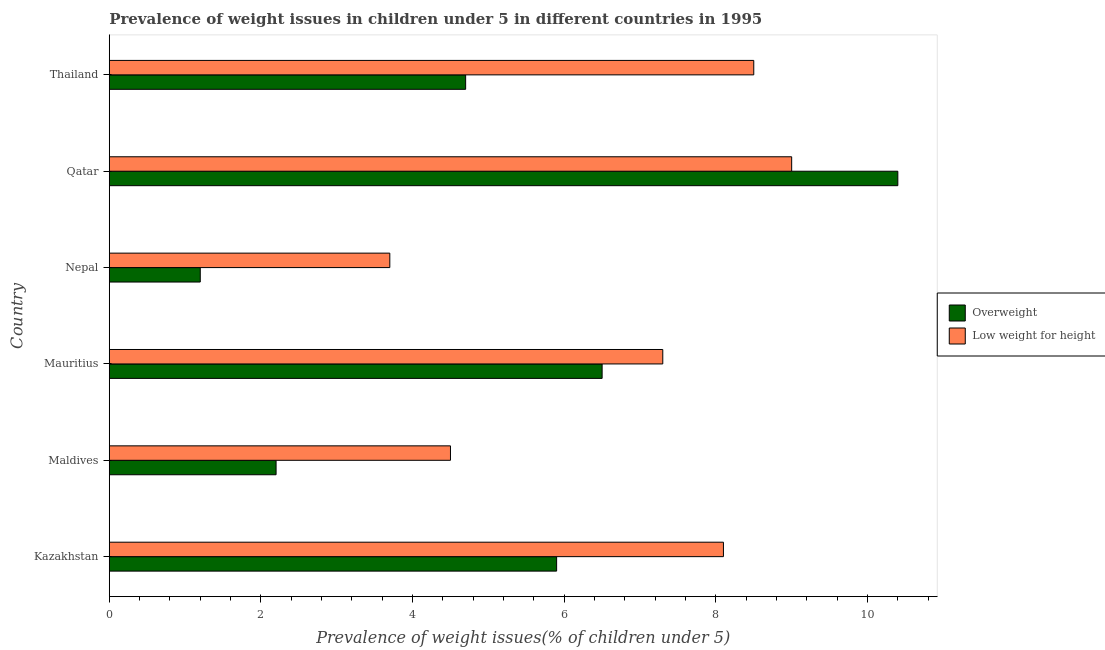How many groups of bars are there?
Keep it short and to the point. 6. Are the number of bars per tick equal to the number of legend labels?
Provide a short and direct response. Yes. What is the label of the 3rd group of bars from the top?
Provide a short and direct response. Nepal. What is the percentage of overweight children in Thailand?
Give a very brief answer. 4.7. Across all countries, what is the maximum percentage of underweight children?
Provide a succinct answer. 9. Across all countries, what is the minimum percentage of underweight children?
Give a very brief answer. 3.7. In which country was the percentage of overweight children maximum?
Offer a very short reply. Qatar. In which country was the percentage of underweight children minimum?
Offer a terse response. Nepal. What is the total percentage of overweight children in the graph?
Provide a succinct answer. 30.9. What is the difference between the percentage of overweight children in Kazakhstan and the percentage of underweight children in Nepal?
Your answer should be very brief. 2.2. What is the average percentage of overweight children per country?
Your response must be concise. 5.15. In how many countries, is the percentage of overweight children greater than 10 %?
Give a very brief answer. 1. What is the ratio of the percentage of underweight children in Kazakhstan to that in Nepal?
Make the answer very short. 2.19. Is the percentage of overweight children in Nepal less than that in Thailand?
Keep it short and to the point. Yes. Is the difference between the percentage of overweight children in Nepal and Qatar greater than the difference between the percentage of underweight children in Nepal and Qatar?
Offer a very short reply. No. What is the difference between the highest and the lowest percentage of underweight children?
Make the answer very short. 5.3. Is the sum of the percentage of underweight children in Nepal and Qatar greater than the maximum percentage of overweight children across all countries?
Offer a terse response. Yes. What does the 2nd bar from the top in Maldives represents?
Make the answer very short. Overweight. What does the 2nd bar from the bottom in Mauritius represents?
Make the answer very short. Low weight for height. What is the difference between two consecutive major ticks on the X-axis?
Your answer should be compact. 2. What is the title of the graph?
Your answer should be very brief. Prevalence of weight issues in children under 5 in different countries in 1995. Does "Males" appear as one of the legend labels in the graph?
Your answer should be compact. No. What is the label or title of the X-axis?
Your answer should be compact. Prevalence of weight issues(% of children under 5). What is the label or title of the Y-axis?
Offer a terse response. Country. What is the Prevalence of weight issues(% of children under 5) in Overweight in Kazakhstan?
Your answer should be very brief. 5.9. What is the Prevalence of weight issues(% of children under 5) of Low weight for height in Kazakhstan?
Offer a very short reply. 8.1. What is the Prevalence of weight issues(% of children under 5) in Overweight in Maldives?
Give a very brief answer. 2.2. What is the Prevalence of weight issues(% of children under 5) of Overweight in Mauritius?
Your response must be concise. 6.5. What is the Prevalence of weight issues(% of children under 5) of Low weight for height in Mauritius?
Give a very brief answer. 7.3. What is the Prevalence of weight issues(% of children under 5) in Overweight in Nepal?
Give a very brief answer. 1.2. What is the Prevalence of weight issues(% of children under 5) in Low weight for height in Nepal?
Give a very brief answer. 3.7. What is the Prevalence of weight issues(% of children under 5) of Overweight in Qatar?
Ensure brevity in your answer.  10.4. What is the Prevalence of weight issues(% of children under 5) in Overweight in Thailand?
Provide a succinct answer. 4.7. Across all countries, what is the maximum Prevalence of weight issues(% of children under 5) of Overweight?
Make the answer very short. 10.4. Across all countries, what is the maximum Prevalence of weight issues(% of children under 5) of Low weight for height?
Provide a short and direct response. 9. Across all countries, what is the minimum Prevalence of weight issues(% of children under 5) in Overweight?
Make the answer very short. 1.2. Across all countries, what is the minimum Prevalence of weight issues(% of children under 5) of Low weight for height?
Make the answer very short. 3.7. What is the total Prevalence of weight issues(% of children under 5) of Overweight in the graph?
Keep it short and to the point. 30.9. What is the total Prevalence of weight issues(% of children under 5) of Low weight for height in the graph?
Provide a succinct answer. 41.1. What is the difference between the Prevalence of weight issues(% of children under 5) in Low weight for height in Kazakhstan and that in Maldives?
Your answer should be very brief. 3.6. What is the difference between the Prevalence of weight issues(% of children under 5) in Overweight in Kazakhstan and that in Mauritius?
Your answer should be very brief. -0.6. What is the difference between the Prevalence of weight issues(% of children under 5) in Low weight for height in Kazakhstan and that in Mauritius?
Make the answer very short. 0.8. What is the difference between the Prevalence of weight issues(% of children under 5) of Overweight in Kazakhstan and that in Nepal?
Ensure brevity in your answer.  4.7. What is the difference between the Prevalence of weight issues(% of children under 5) in Overweight in Kazakhstan and that in Qatar?
Provide a succinct answer. -4.5. What is the difference between the Prevalence of weight issues(% of children under 5) in Overweight in Kazakhstan and that in Thailand?
Provide a short and direct response. 1.2. What is the difference between the Prevalence of weight issues(% of children under 5) of Low weight for height in Kazakhstan and that in Thailand?
Offer a terse response. -0.4. What is the difference between the Prevalence of weight issues(% of children under 5) of Low weight for height in Maldives and that in Mauritius?
Ensure brevity in your answer.  -2.8. What is the difference between the Prevalence of weight issues(% of children under 5) of Low weight for height in Maldives and that in Thailand?
Ensure brevity in your answer.  -4. What is the difference between the Prevalence of weight issues(% of children under 5) of Low weight for height in Mauritius and that in Nepal?
Give a very brief answer. 3.6. What is the difference between the Prevalence of weight issues(% of children under 5) in Overweight in Mauritius and that in Qatar?
Provide a short and direct response. -3.9. What is the difference between the Prevalence of weight issues(% of children under 5) in Low weight for height in Mauritius and that in Qatar?
Provide a succinct answer. -1.7. What is the difference between the Prevalence of weight issues(% of children under 5) of Low weight for height in Mauritius and that in Thailand?
Ensure brevity in your answer.  -1.2. What is the difference between the Prevalence of weight issues(% of children under 5) of Low weight for height in Nepal and that in Qatar?
Give a very brief answer. -5.3. What is the difference between the Prevalence of weight issues(% of children under 5) of Overweight in Nepal and that in Thailand?
Offer a terse response. -3.5. What is the difference between the Prevalence of weight issues(% of children under 5) in Overweight in Qatar and that in Thailand?
Your answer should be compact. 5.7. What is the difference between the Prevalence of weight issues(% of children under 5) in Overweight in Kazakhstan and the Prevalence of weight issues(% of children under 5) in Low weight for height in Maldives?
Offer a terse response. 1.4. What is the difference between the Prevalence of weight issues(% of children under 5) in Overweight in Maldives and the Prevalence of weight issues(% of children under 5) in Low weight for height in Mauritius?
Provide a succinct answer. -5.1. What is the difference between the Prevalence of weight issues(% of children under 5) in Overweight in Maldives and the Prevalence of weight issues(% of children under 5) in Low weight for height in Nepal?
Your answer should be very brief. -1.5. What is the difference between the Prevalence of weight issues(% of children under 5) of Overweight in Maldives and the Prevalence of weight issues(% of children under 5) of Low weight for height in Thailand?
Your answer should be very brief. -6.3. What is the difference between the Prevalence of weight issues(% of children under 5) in Overweight in Mauritius and the Prevalence of weight issues(% of children under 5) in Low weight for height in Thailand?
Offer a very short reply. -2. What is the difference between the Prevalence of weight issues(% of children under 5) in Overweight in Nepal and the Prevalence of weight issues(% of children under 5) in Low weight for height in Thailand?
Give a very brief answer. -7.3. What is the difference between the Prevalence of weight issues(% of children under 5) in Overweight in Qatar and the Prevalence of weight issues(% of children under 5) in Low weight for height in Thailand?
Offer a very short reply. 1.9. What is the average Prevalence of weight issues(% of children under 5) in Overweight per country?
Keep it short and to the point. 5.15. What is the average Prevalence of weight issues(% of children under 5) in Low weight for height per country?
Your response must be concise. 6.85. What is the difference between the Prevalence of weight issues(% of children under 5) in Overweight and Prevalence of weight issues(% of children under 5) in Low weight for height in Maldives?
Make the answer very short. -2.3. What is the difference between the Prevalence of weight issues(% of children under 5) of Overweight and Prevalence of weight issues(% of children under 5) of Low weight for height in Nepal?
Offer a terse response. -2.5. What is the difference between the Prevalence of weight issues(% of children under 5) in Overweight and Prevalence of weight issues(% of children under 5) in Low weight for height in Thailand?
Your response must be concise. -3.8. What is the ratio of the Prevalence of weight issues(% of children under 5) in Overweight in Kazakhstan to that in Maldives?
Offer a very short reply. 2.68. What is the ratio of the Prevalence of weight issues(% of children under 5) in Low weight for height in Kazakhstan to that in Maldives?
Your answer should be very brief. 1.8. What is the ratio of the Prevalence of weight issues(% of children under 5) of Overweight in Kazakhstan to that in Mauritius?
Give a very brief answer. 0.91. What is the ratio of the Prevalence of weight issues(% of children under 5) of Low weight for height in Kazakhstan to that in Mauritius?
Make the answer very short. 1.11. What is the ratio of the Prevalence of weight issues(% of children under 5) of Overweight in Kazakhstan to that in Nepal?
Ensure brevity in your answer.  4.92. What is the ratio of the Prevalence of weight issues(% of children under 5) of Low weight for height in Kazakhstan to that in Nepal?
Give a very brief answer. 2.19. What is the ratio of the Prevalence of weight issues(% of children under 5) of Overweight in Kazakhstan to that in Qatar?
Offer a terse response. 0.57. What is the ratio of the Prevalence of weight issues(% of children under 5) of Low weight for height in Kazakhstan to that in Qatar?
Keep it short and to the point. 0.9. What is the ratio of the Prevalence of weight issues(% of children under 5) of Overweight in Kazakhstan to that in Thailand?
Keep it short and to the point. 1.26. What is the ratio of the Prevalence of weight issues(% of children under 5) in Low weight for height in Kazakhstan to that in Thailand?
Keep it short and to the point. 0.95. What is the ratio of the Prevalence of weight issues(% of children under 5) in Overweight in Maldives to that in Mauritius?
Ensure brevity in your answer.  0.34. What is the ratio of the Prevalence of weight issues(% of children under 5) of Low weight for height in Maldives to that in Mauritius?
Your response must be concise. 0.62. What is the ratio of the Prevalence of weight issues(% of children under 5) in Overweight in Maldives to that in Nepal?
Your answer should be very brief. 1.83. What is the ratio of the Prevalence of weight issues(% of children under 5) in Low weight for height in Maldives to that in Nepal?
Offer a very short reply. 1.22. What is the ratio of the Prevalence of weight issues(% of children under 5) in Overweight in Maldives to that in Qatar?
Make the answer very short. 0.21. What is the ratio of the Prevalence of weight issues(% of children under 5) of Overweight in Maldives to that in Thailand?
Ensure brevity in your answer.  0.47. What is the ratio of the Prevalence of weight issues(% of children under 5) of Low weight for height in Maldives to that in Thailand?
Offer a terse response. 0.53. What is the ratio of the Prevalence of weight issues(% of children under 5) in Overweight in Mauritius to that in Nepal?
Ensure brevity in your answer.  5.42. What is the ratio of the Prevalence of weight issues(% of children under 5) in Low weight for height in Mauritius to that in Nepal?
Offer a very short reply. 1.97. What is the ratio of the Prevalence of weight issues(% of children under 5) in Overweight in Mauritius to that in Qatar?
Your response must be concise. 0.62. What is the ratio of the Prevalence of weight issues(% of children under 5) of Low weight for height in Mauritius to that in Qatar?
Provide a succinct answer. 0.81. What is the ratio of the Prevalence of weight issues(% of children under 5) of Overweight in Mauritius to that in Thailand?
Your response must be concise. 1.38. What is the ratio of the Prevalence of weight issues(% of children under 5) in Low weight for height in Mauritius to that in Thailand?
Ensure brevity in your answer.  0.86. What is the ratio of the Prevalence of weight issues(% of children under 5) in Overweight in Nepal to that in Qatar?
Ensure brevity in your answer.  0.12. What is the ratio of the Prevalence of weight issues(% of children under 5) of Low weight for height in Nepal to that in Qatar?
Make the answer very short. 0.41. What is the ratio of the Prevalence of weight issues(% of children under 5) in Overweight in Nepal to that in Thailand?
Give a very brief answer. 0.26. What is the ratio of the Prevalence of weight issues(% of children under 5) in Low weight for height in Nepal to that in Thailand?
Give a very brief answer. 0.44. What is the ratio of the Prevalence of weight issues(% of children under 5) of Overweight in Qatar to that in Thailand?
Make the answer very short. 2.21. What is the ratio of the Prevalence of weight issues(% of children under 5) in Low weight for height in Qatar to that in Thailand?
Offer a terse response. 1.06. What is the difference between the highest and the lowest Prevalence of weight issues(% of children under 5) of Overweight?
Offer a very short reply. 9.2. What is the difference between the highest and the lowest Prevalence of weight issues(% of children under 5) in Low weight for height?
Provide a short and direct response. 5.3. 